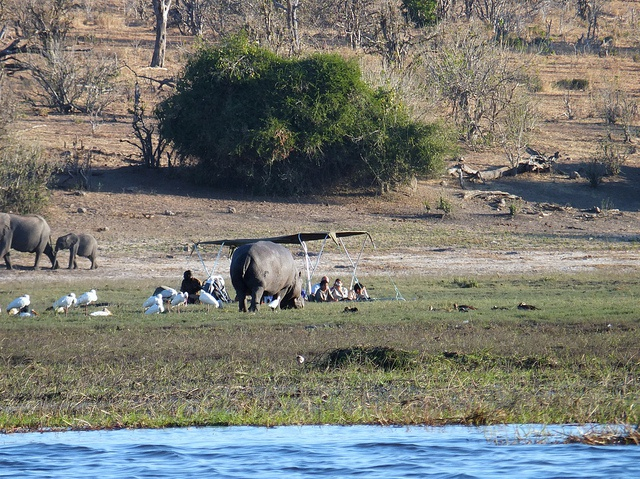Describe the objects in this image and their specific colors. I can see elephant in gray, black, darkgray, and lightgray tones, elephant in gray, black, and darkgray tones, elephant in gray, black, and darkgray tones, people in gray, black, ivory, and darkgray tones, and bird in gray, white, and darkgray tones in this image. 